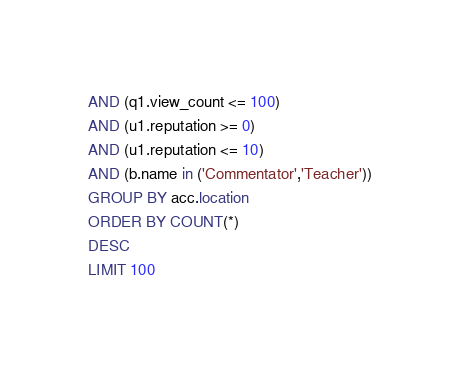<code> <loc_0><loc_0><loc_500><loc_500><_SQL_>AND (q1.view_count <= 100)
AND (u1.reputation >= 0)
AND (u1.reputation <= 10)
AND (b.name in ('Commentator','Teacher'))
GROUP BY acc.location
ORDER BY COUNT(*)
DESC
LIMIT 100
</code> 